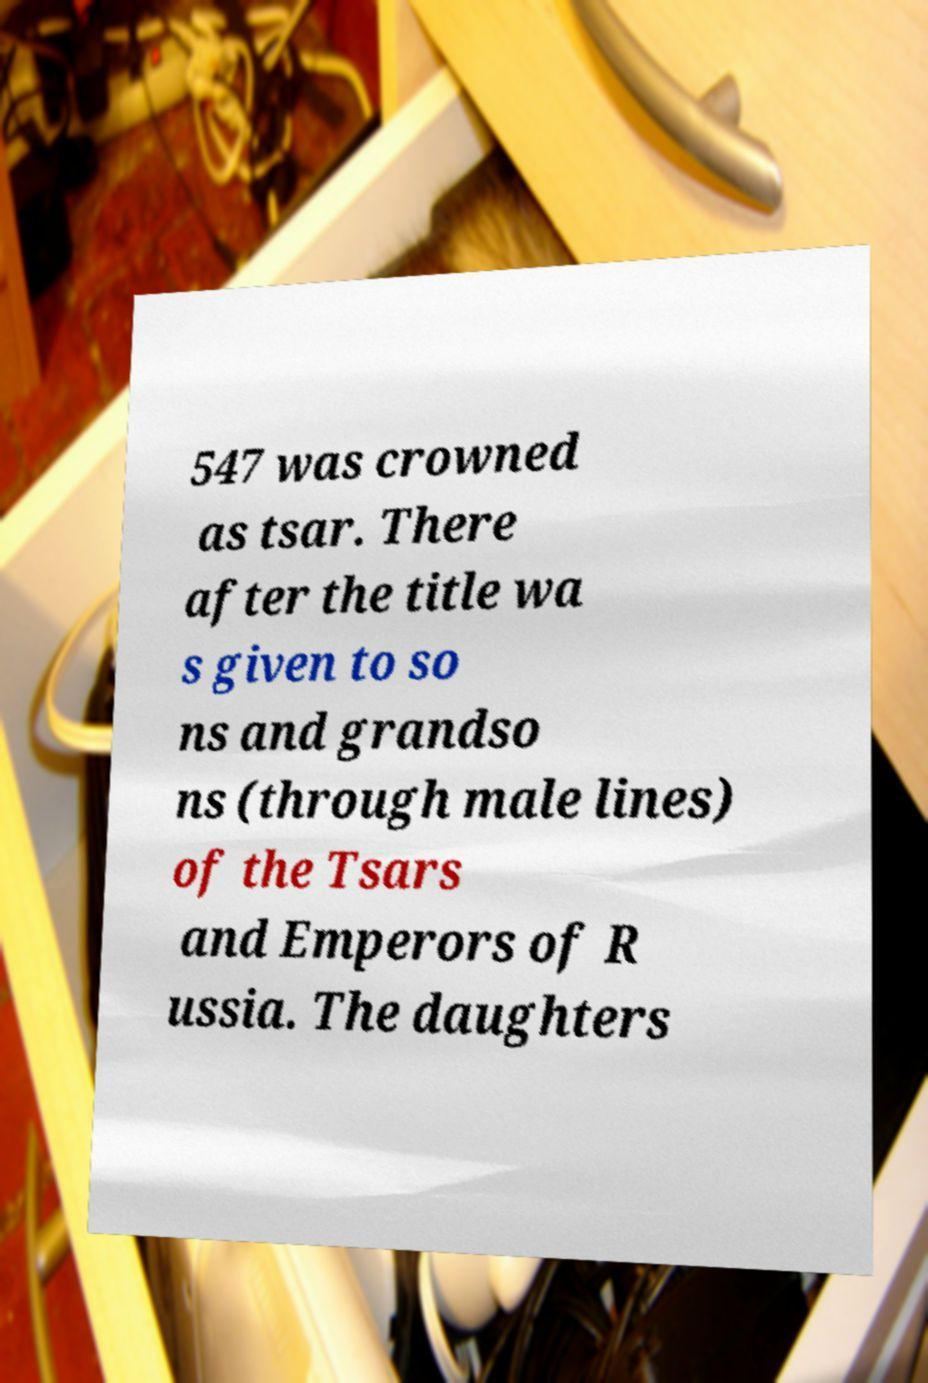There's text embedded in this image that I need extracted. Can you transcribe it verbatim? 547 was crowned as tsar. There after the title wa s given to so ns and grandso ns (through male lines) of the Tsars and Emperors of R ussia. The daughters 